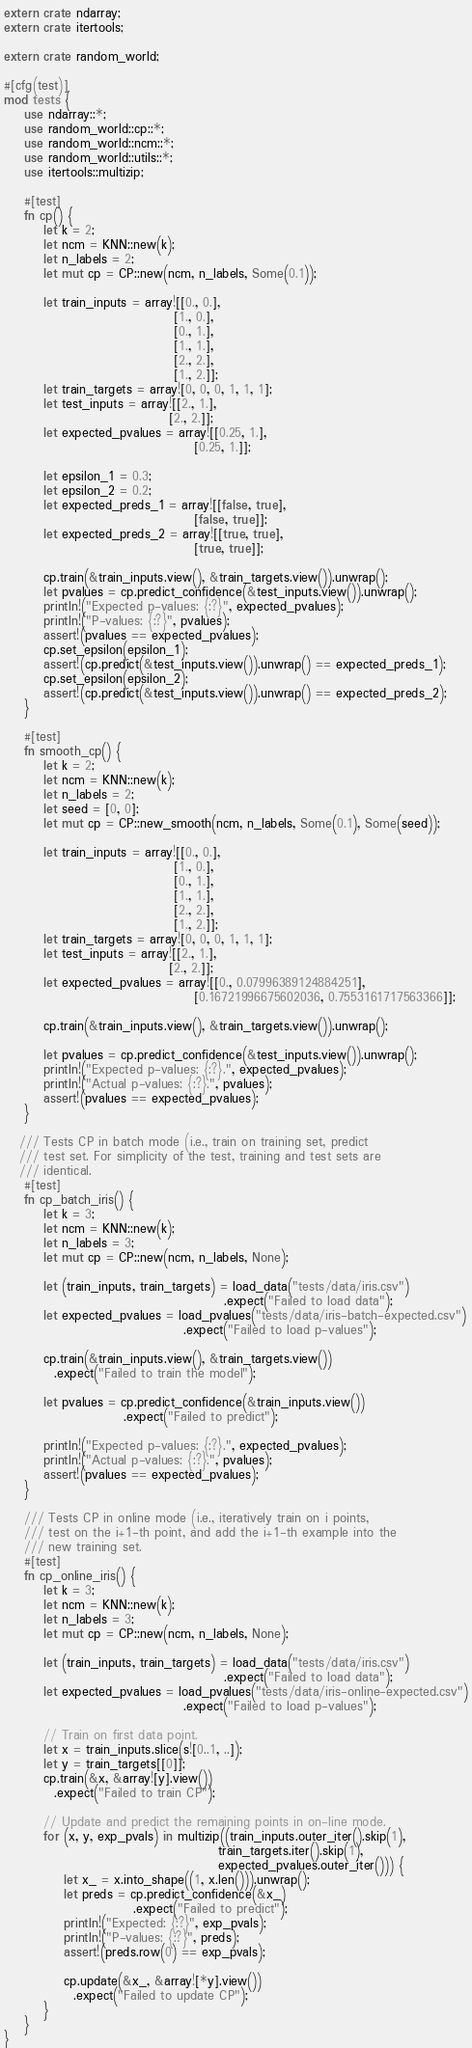<code> <loc_0><loc_0><loc_500><loc_500><_Rust_>extern crate ndarray;
extern crate itertools;

extern crate random_world;

#[cfg(test)]
mod tests {
    use ndarray::*;
    use random_world::cp::*;
    use random_world::ncm::*;
    use random_world::utils::*;
    use itertools::multizip;
    
    #[test]
    fn cp() {
        let k = 2;
        let ncm = KNN::new(k);
        let n_labels = 2;
        let mut cp = CP::new(ncm, n_labels, Some(0.1));

        let train_inputs = array![[0., 0.],
                                  [1., 0.],
                                  [0., 1.],
                                  [1., 1.],
                                  [2., 2.],
                                  [1., 2.]];
        let train_targets = array![0, 0, 0, 1, 1, 1];
        let test_inputs = array![[2., 1.],
                                 [2., 2.]];
        let expected_pvalues = array![[0.25, 1.],
                                      [0.25, 1.]];

        let epsilon_1 = 0.3;
        let epsilon_2 = 0.2;
        let expected_preds_1 = array![[false, true],
                                      [false, true]];
        let expected_preds_2 = array![[true, true],
                                      [true, true]];

        cp.train(&train_inputs.view(), &train_targets.view()).unwrap();
        let pvalues = cp.predict_confidence(&test_inputs.view()).unwrap();
        println!("Expected p-values: {:?}", expected_pvalues);
        println!("P-values: {:?}", pvalues);
        assert!(pvalues == expected_pvalues);
        cp.set_epsilon(epsilon_1);
        assert!(cp.predict(&test_inputs.view()).unwrap() == expected_preds_1);
        cp.set_epsilon(epsilon_2);
        assert!(cp.predict(&test_inputs.view()).unwrap() == expected_preds_2);
    }

    #[test]
    fn smooth_cp() {
        let k = 2;
        let ncm = KNN::new(k);
        let n_labels = 2;
        let seed = [0, 0];
        let mut cp = CP::new_smooth(ncm, n_labels, Some(0.1), Some(seed));

        let train_inputs = array![[0., 0.],
                                  [1., 0.],
                                  [0., 1.],
                                  [1., 1.],
                                  [2., 2.],
                                  [1., 2.]];
        let train_targets = array![0, 0, 0, 1, 1, 1];
        let test_inputs = array![[2., 1.],
                                 [2., 2.]];
        let expected_pvalues = array![[0., 0.07996389124884251],
                                      [0.16721996675602036, 0.7553161717563366]];

        cp.train(&train_inputs.view(), &train_targets.view()).unwrap();

        let pvalues = cp.predict_confidence(&test_inputs.view()).unwrap();
        println!("Expected p-values: {:?}.", expected_pvalues);
        println!("Actual p-values: {:?}.", pvalues);
        assert!(pvalues == expected_pvalues);
    }

   /// Tests CP in batch mode (i.e., train on training set, predict
   /// test set. For simplicity of the test, training and test sets are
   /// identical.
    #[test]
    fn cp_batch_iris() {
        let k = 3;
        let ncm = KNN::new(k);
        let n_labels = 3;
        let mut cp = CP::new(ncm, n_labels, None);

        let (train_inputs, train_targets) = load_data("tests/data/iris.csv")
                                            .expect("Failed to load data");
        let expected_pvalues = load_pvalues("tests/data/iris-batch-expected.csv")
                                    .expect("Failed to load p-values");

        cp.train(&train_inputs.view(), &train_targets.view())
          .expect("Failed to train the model");

        let pvalues = cp.predict_confidence(&train_inputs.view())
                        .expect("Failed to predict");

        println!("Expected p-values: {:?}.", expected_pvalues);
        println!("Actual p-values: {:?}.", pvalues);
        assert!(pvalues == expected_pvalues);
    }

    /// Tests CP in online mode (i.e., iteratively train on i points,
    /// test on the i+1-th point, and add the i+1-th example into the
    /// new training set.
    #[test]
    fn cp_online_iris() {
        let k = 3;
        let ncm = KNN::new(k);
        let n_labels = 3;
        let mut cp = CP::new(ncm, n_labels, None);

        let (train_inputs, train_targets) = load_data("tests/data/iris.csv")
                                            .expect("Failed to load data");
        let expected_pvalues = load_pvalues("tests/data/iris-online-expected.csv")
                                    .expect("Failed to load p-values");

        // Train on first data point.
        let x = train_inputs.slice(s![0..1, ..]);
        let y = train_targets[[0]];
        cp.train(&x, &array![y].view())
          .expect("Failed to train CP");

        // Update and predict the remaining points in on-line mode.
        for (x, y, exp_pvals) in multizip((train_inputs.outer_iter().skip(1),
                                           train_targets.iter().skip(1),
                                           expected_pvalues.outer_iter())) {
            let x_ = x.into_shape((1, x.len())).unwrap();
            let preds = cp.predict_confidence(&x_)
                          .expect("Failed to predict");
            println!("Expected: {:?}", exp_pvals);
            println!("P-values: {:?}", preds);
            assert!(preds.row(0) == exp_pvals);

            cp.update(&x_, &array![*y].view())
              .expect("Failed to update CP");
        }
    }
}
</code> 